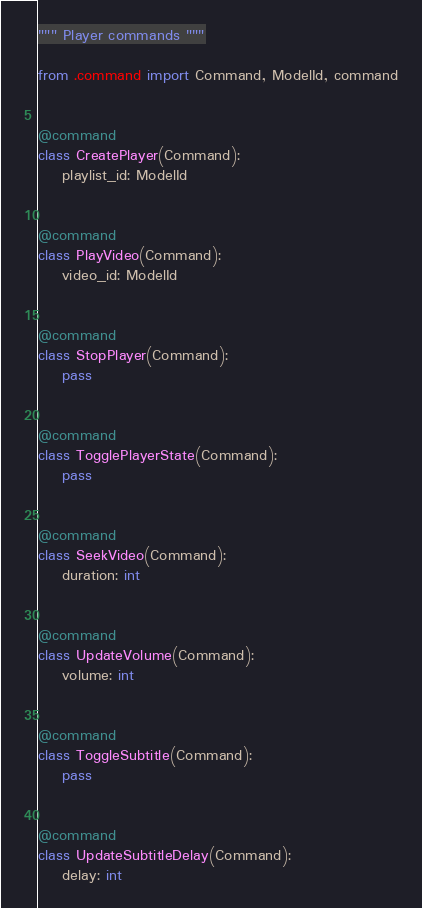<code> <loc_0><loc_0><loc_500><loc_500><_Python_>""" Player commands """

from .command import Command, ModelId, command


@command
class CreatePlayer(Command):
    playlist_id: ModelId


@command
class PlayVideo(Command):
    video_id: ModelId


@command
class StopPlayer(Command):
    pass


@command
class TogglePlayerState(Command):
    pass


@command
class SeekVideo(Command):
    duration: int


@command
class UpdateVolume(Command):
    volume: int


@command
class ToggleSubtitle(Command):
    pass


@command
class UpdateSubtitleDelay(Command):
    delay: int
</code> 